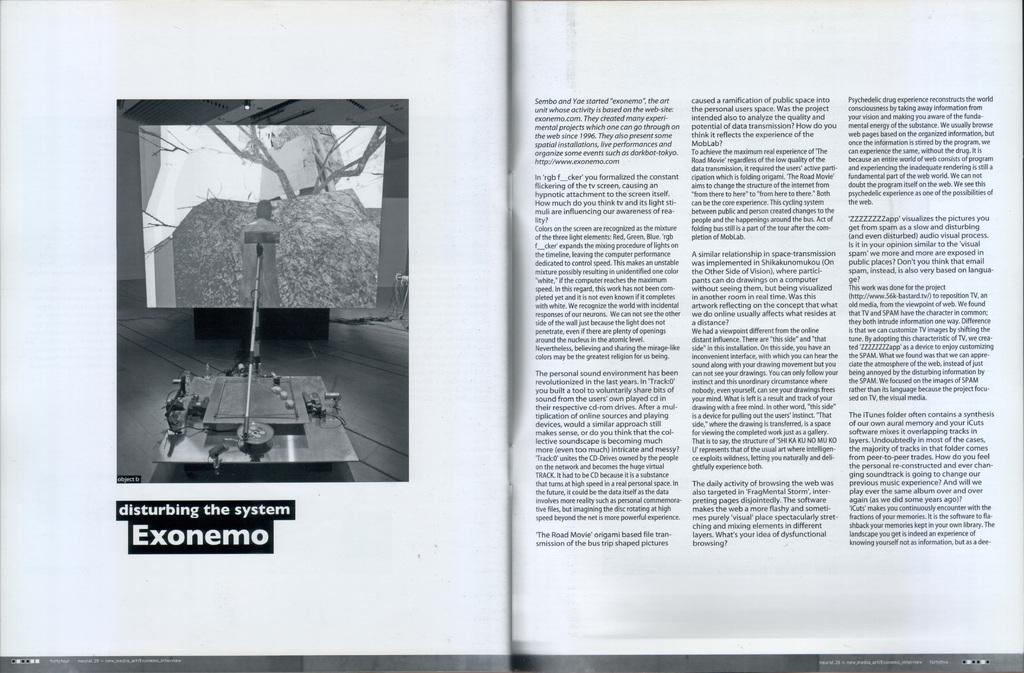What word is written on the left page?
Keep it short and to the point. Exonemo. 